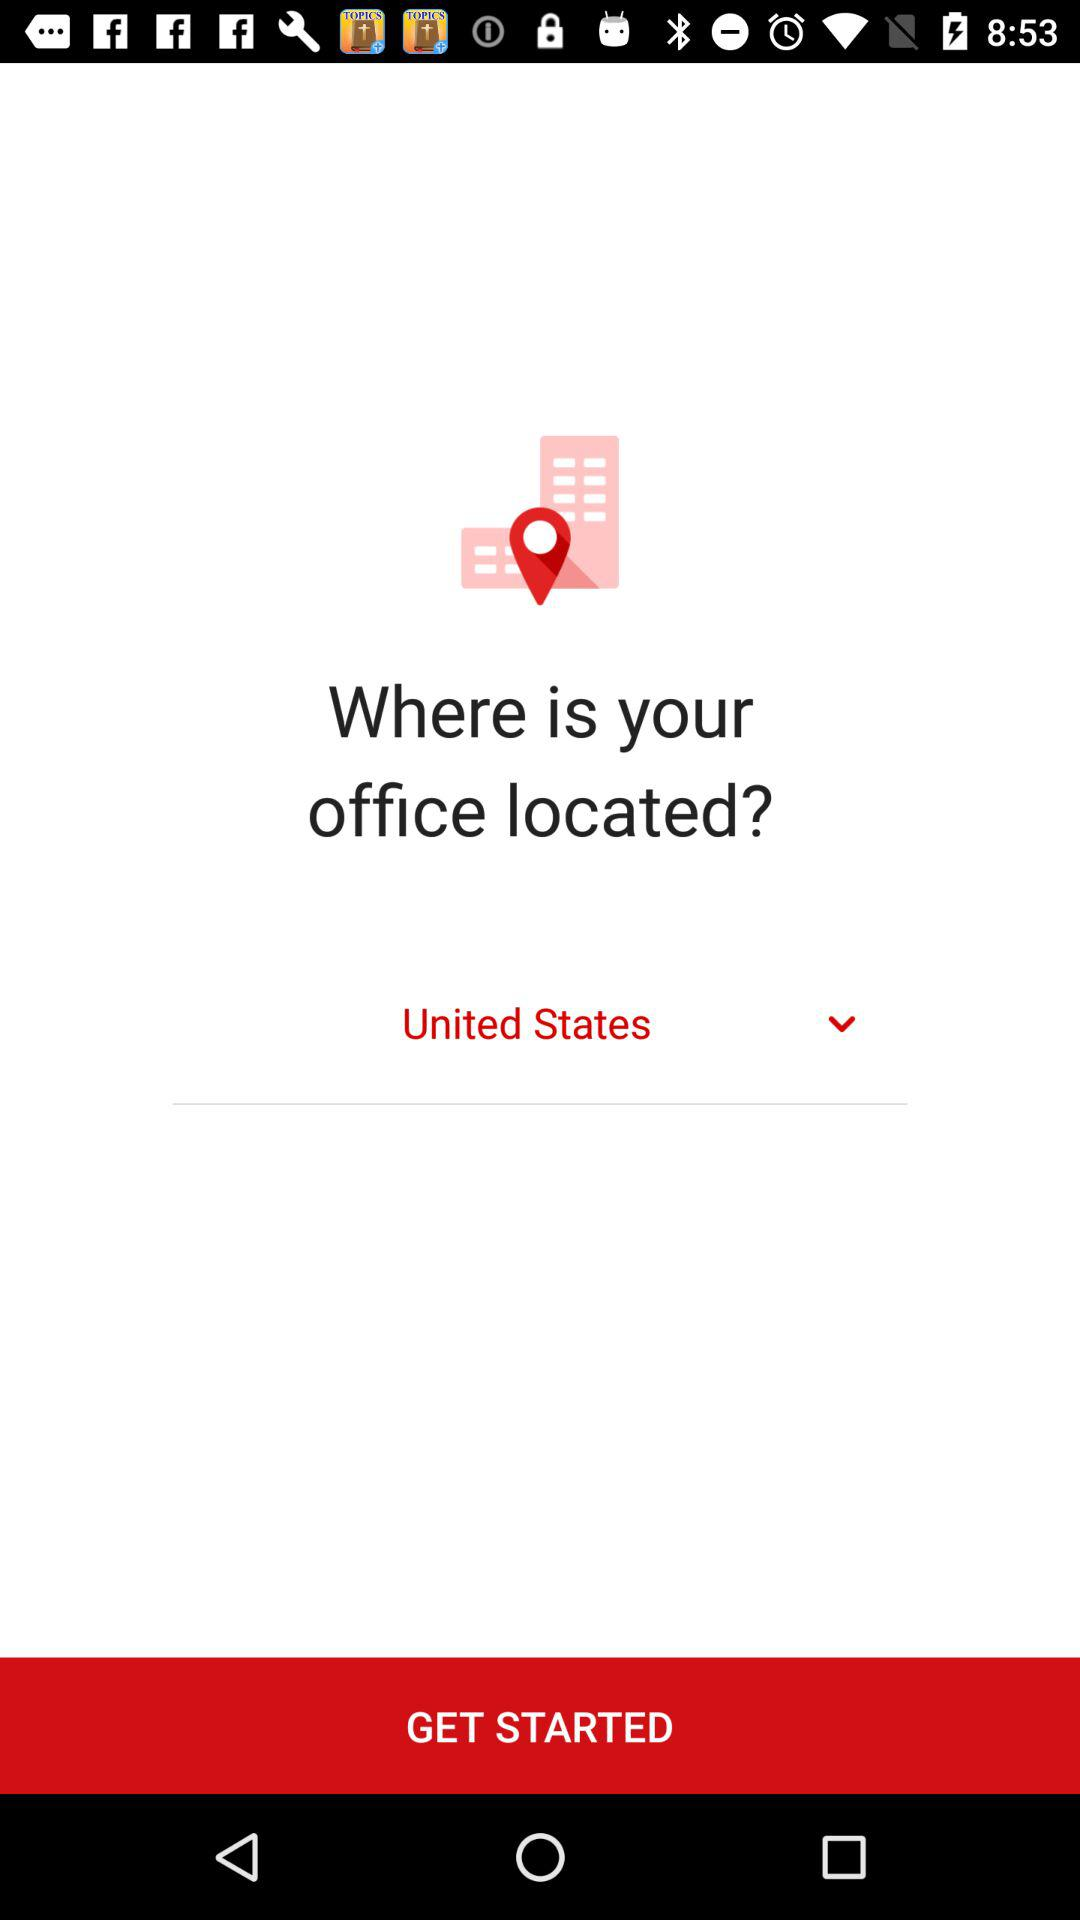Which country is selected? The selected country is United States. 